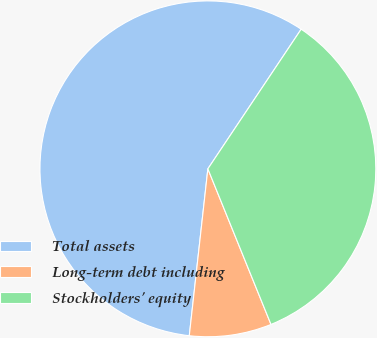Convert chart to OTSL. <chart><loc_0><loc_0><loc_500><loc_500><pie_chart><fcel>Total assets<fcel>Long-term debt including<fcel>Stockholders' equity<nl><fcel>57.61%<fcel>7.9%<fcel>34.49%<nl></chart> 